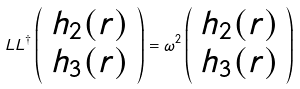Convert formula to latex. <formula><loc_0><loc_0><loc_500><loc_500>L L ^ { \dagger } \left ( \begin{array} { c } h _ { 2 } ( r ) \\ h _ { 3 } ( r ) \end{array} \right ) = \omega ^ { 2 } \left ( \begin{array} { c } h _ { 2 } ( r ) \\ h _ { 3 } ( r ) \end{array} \right )</formula> 